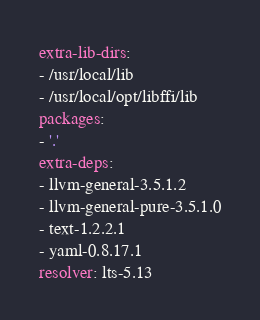<code> <loc_0><loc_0><loc_500><loc_500><_YAML_>extra-lib-dirs:
- /usr/local/lib
- /usr/local/opt/libffi/lib
packages:
- '.'
extra-deps:
- llvm-general-3.5.1.2
- llvm-general-pure-3.5.1.0
- text-1.2.2.1
- yaml-0.8.17.1
resolver: lts-5.13
</code> 